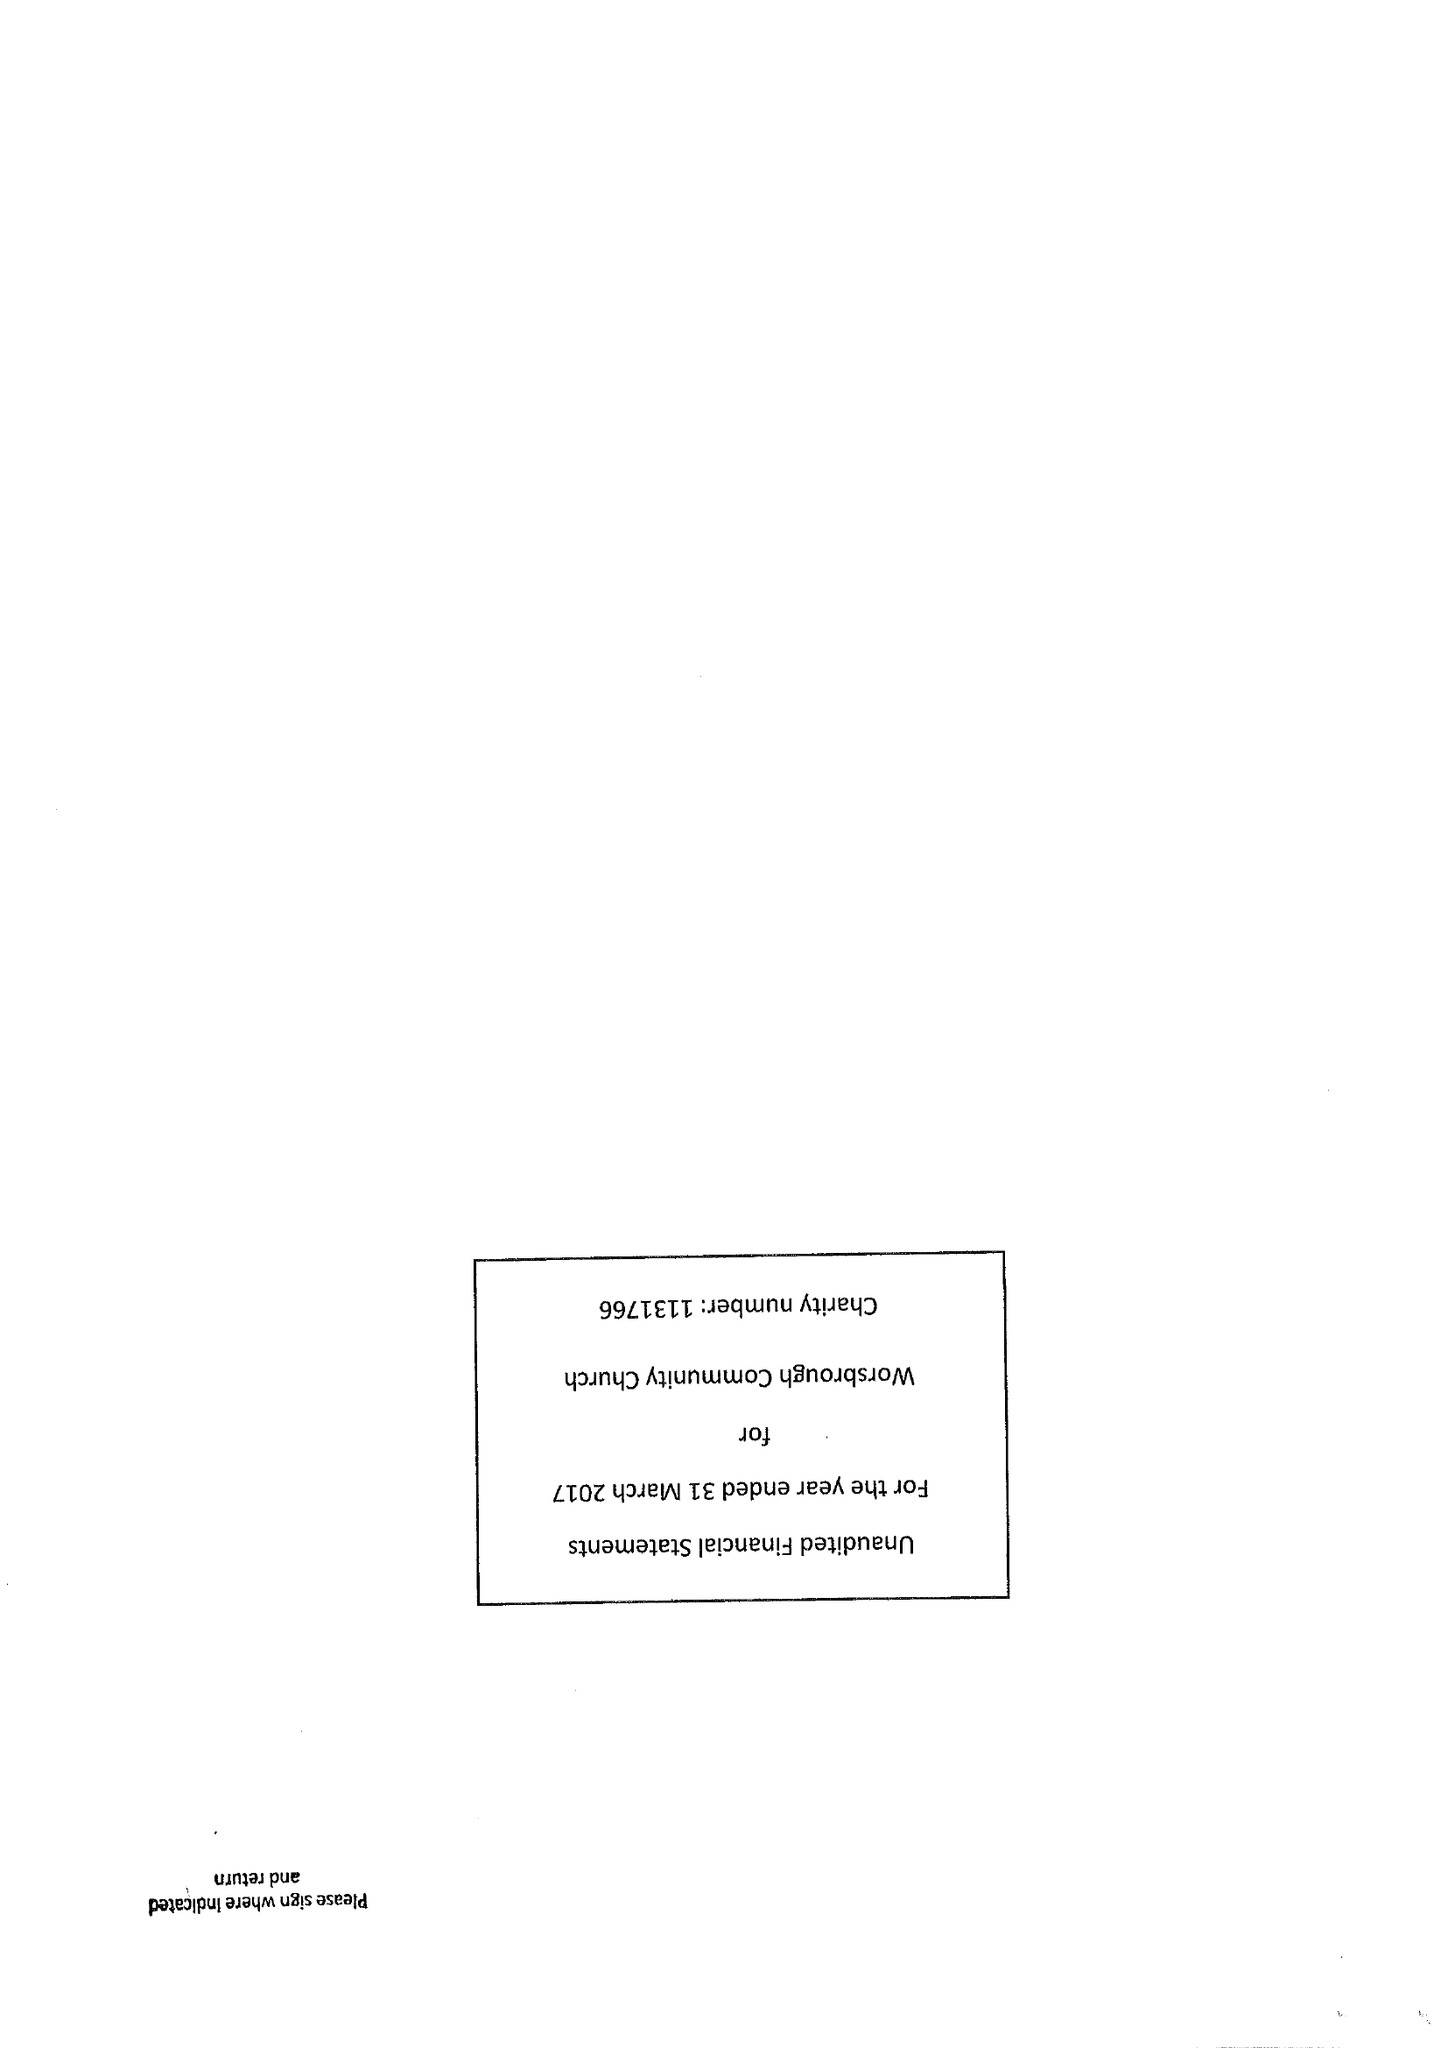What is the value for the address__post_town?
Answer the question using a single word or phrase. BARNSLEY 